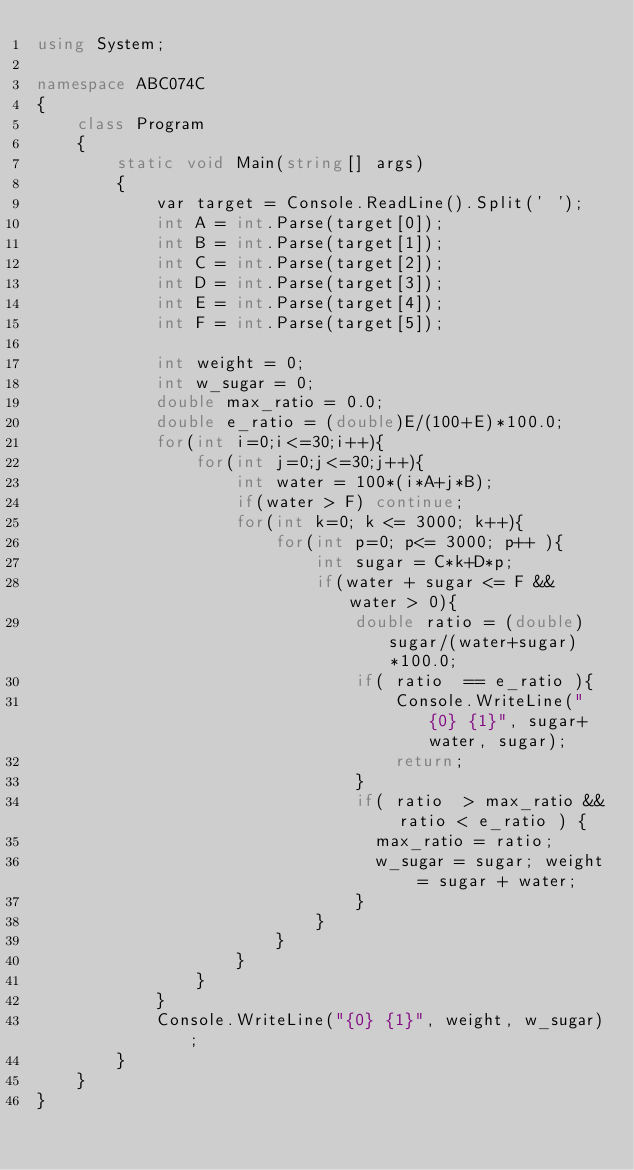Convert code to text. <code><loc_0><loc_0><loc_500><loc_500><_C#_>using System;

namespace ABC074C
{
    class Program
    {
        static void Main(string[] args)
        {
            var target = Console.ReadLine().Split(' ');
            int A = int.Parse(target[0]);
            int B = int.Parse(target[1]);
            int C = int.Parse(target[2]);
            int D = int.Parse(target[3]);
            int E = int.Parse(target[4]);
            int F = int.Parse(target[5]);

            int weight = 0;
            int w_sugar = 0;
            double max_ratio = 0.0;
            double e_ratio = (double)E/(100+E)*100.0;
            for(int i=0;i<=30;i++){
                for(int j=0;j<=30;j++){
                    int water = 100*(i*A+j*B); 
                    if(water > F) continue;
                    for(int k=0; k <= 3000; k++){
                        for(int p=0; p<= 3000; p++ ){
                            int sugar = C*k+D*p; 
                            if(water + sugar <= F && water > 0){
                                double ratio = (double)sugar/(water+sugar)*100.0;
                                if( ratio  == e_ratio ){
                                    Console.WriteLine("{0} {1}", sugar+water, sugar);
                                    return;
                                }
                                if( ratio  > max_ratio && ratio < e_ratio ) {
                                  max_ratio = ratio;      
                                  w_sugar = sugar; weight = sugar + water;
                                }
                            }
                        }
                    }                    
                }
            }
            Console.WriteLine("{0} {1}", weight, w_sugar);
        }
    }
}
</code> 